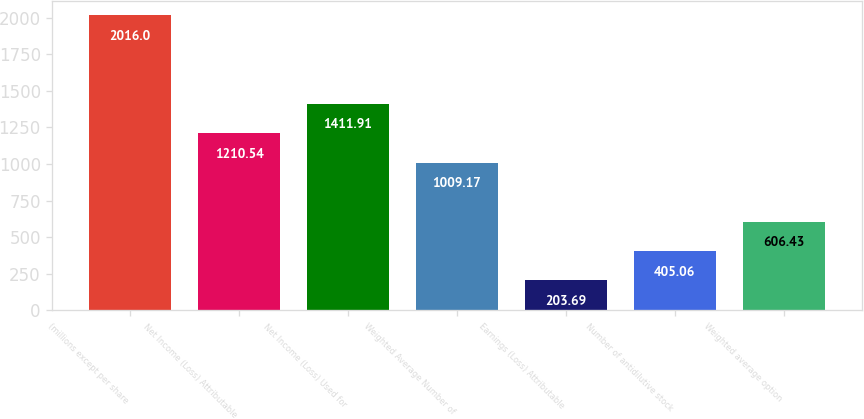<chart> <loc_0><loc_0><loc_500><loc_500><bar_chart><fcel>(millions except per share<fcel>Net Income (Loss) Attributable<fcel>Net Income (Loss) Used for<fcel>Weighted Average Number of<fcel>Earnings (Loss) Attributable<fcel>Number of antidilutive stock<fcel>Weighted average option<nl><fcel>2016<fcel>1210.54<fcel>1411.91<fcel>1009.17<fcel>203.69<fcel>405.06<fcel>606.43<nl></chart> 